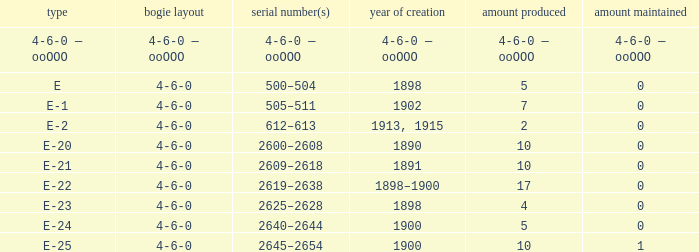What is the wheel arrangement made in 1890? 4-6-0. 